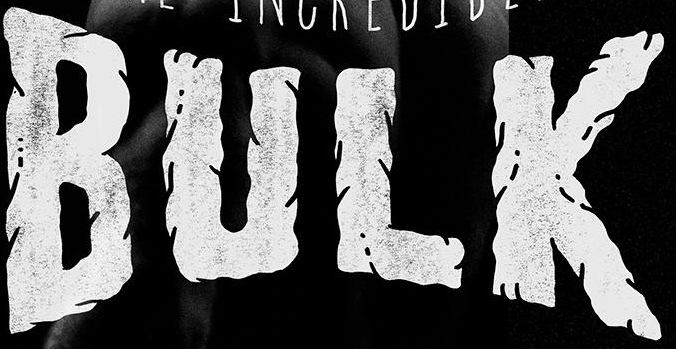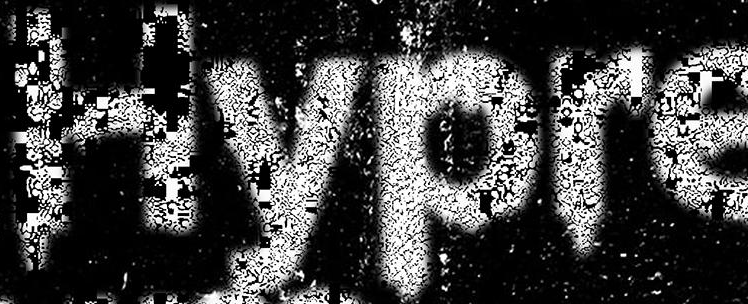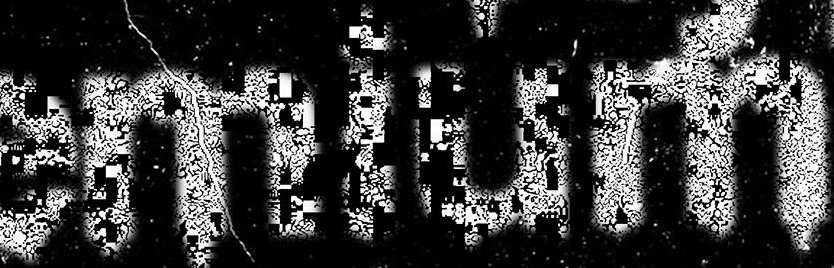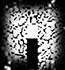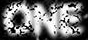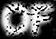What text is displayed in these images sequentially, separated by a semicolon? BULK; Hypre; emium; .; ONE; OF 